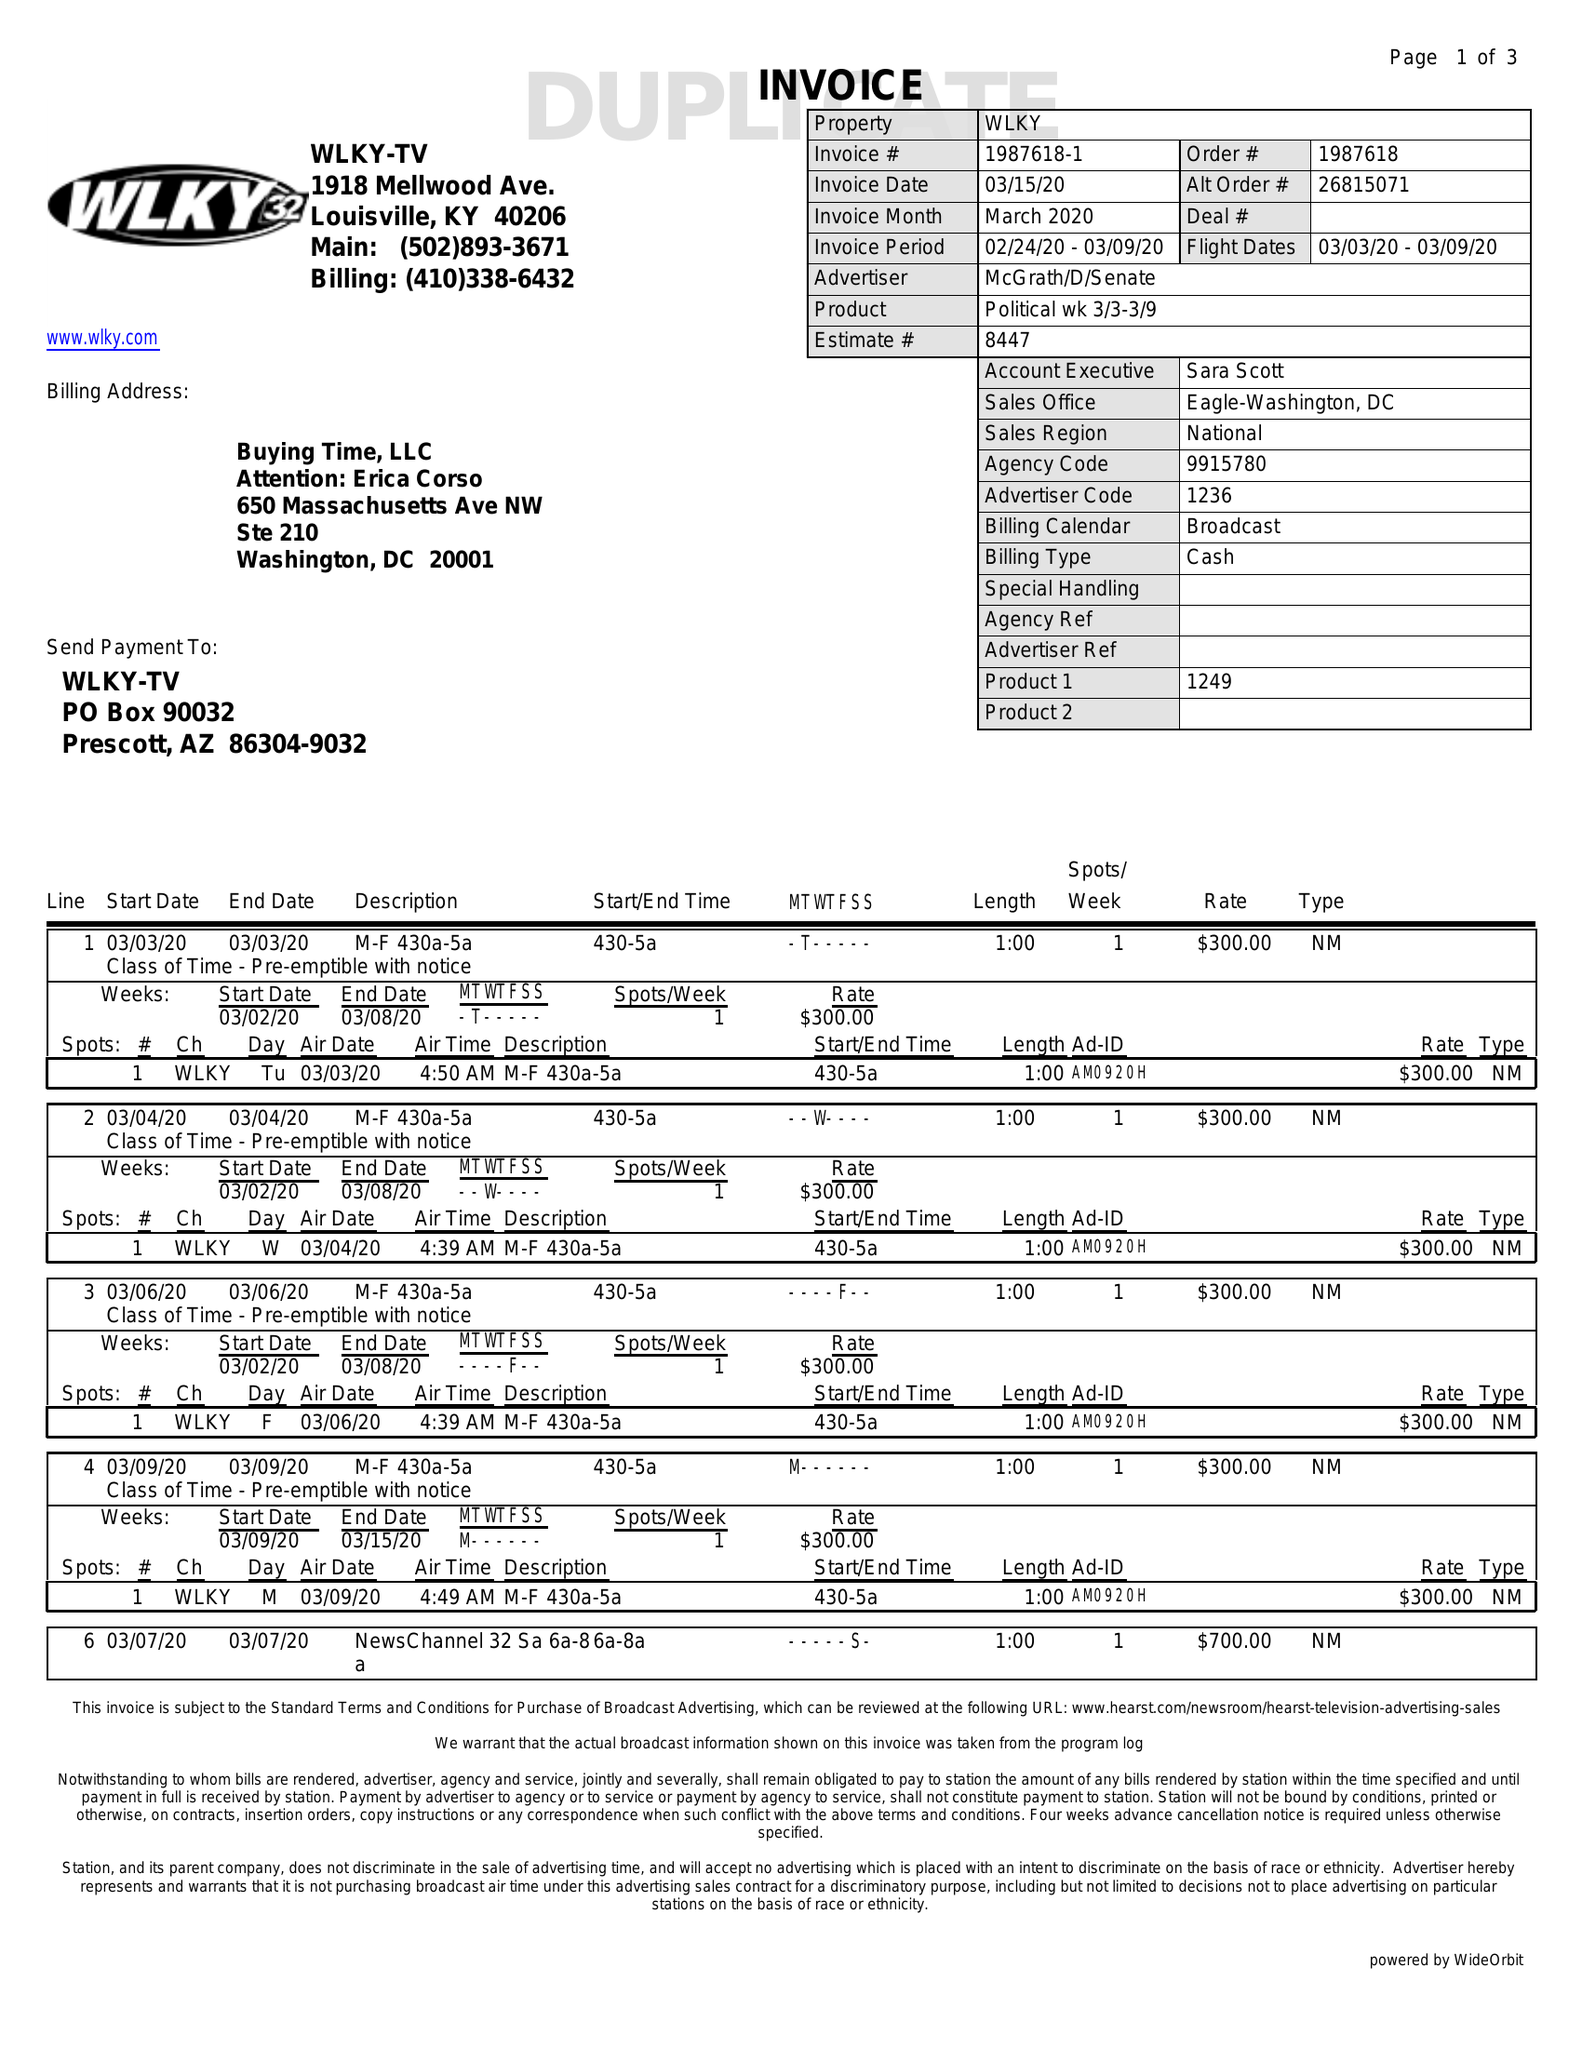What is the value for the flight_to?
Answer the question using a single word or phrase. 03/09/20 